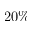<formula> <loc_0><loc_0><loc_500><loc_500>2 0 \%</formula> 